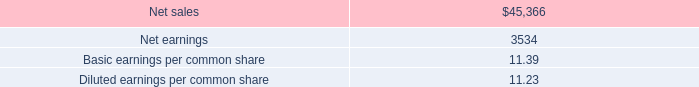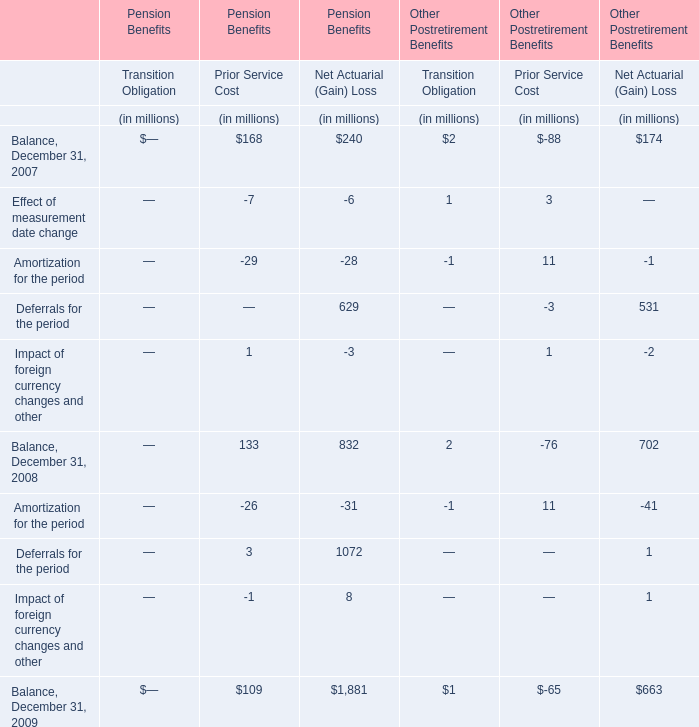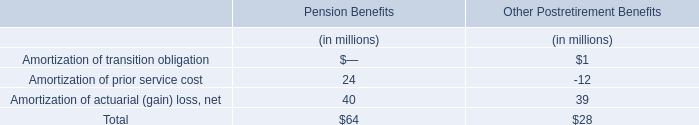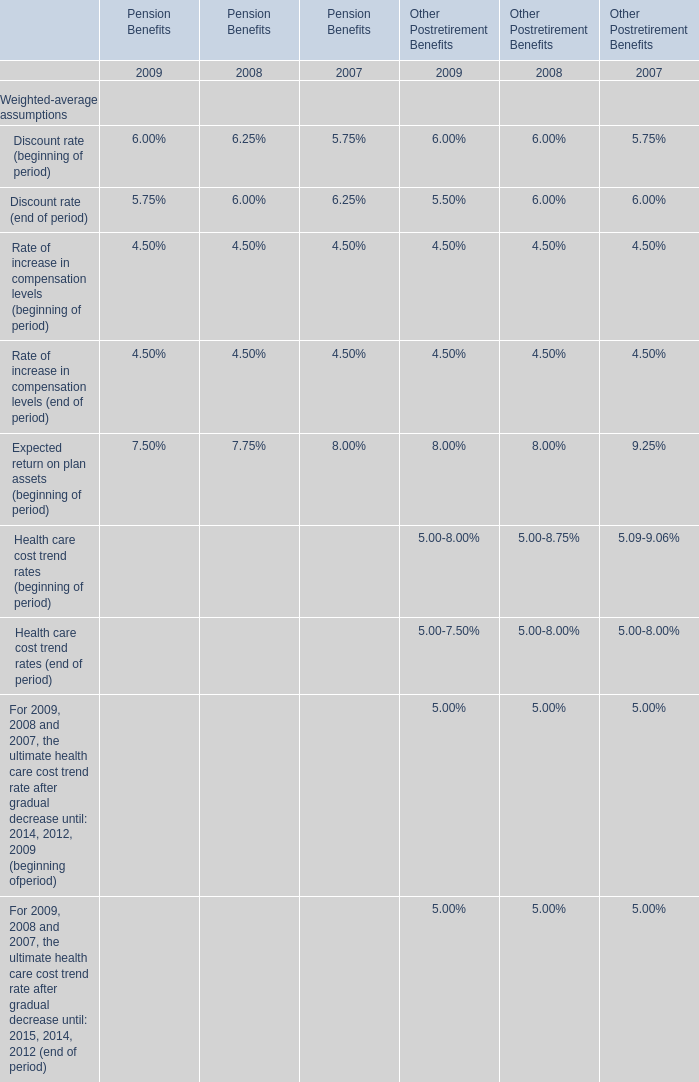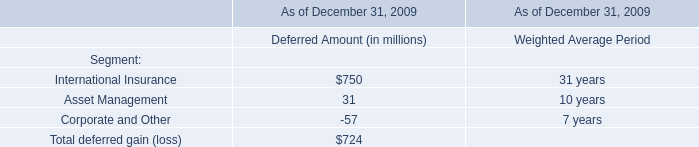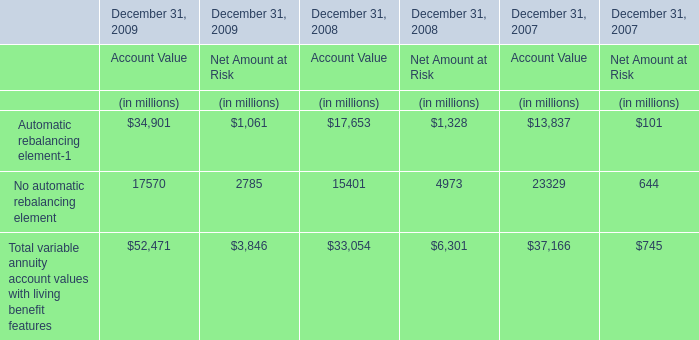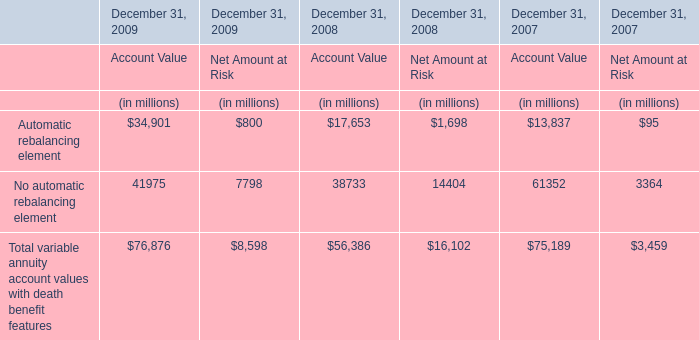The total amount of which section ranks first for Prior Service Cost? 
Answer: Effect of measurement date change. 